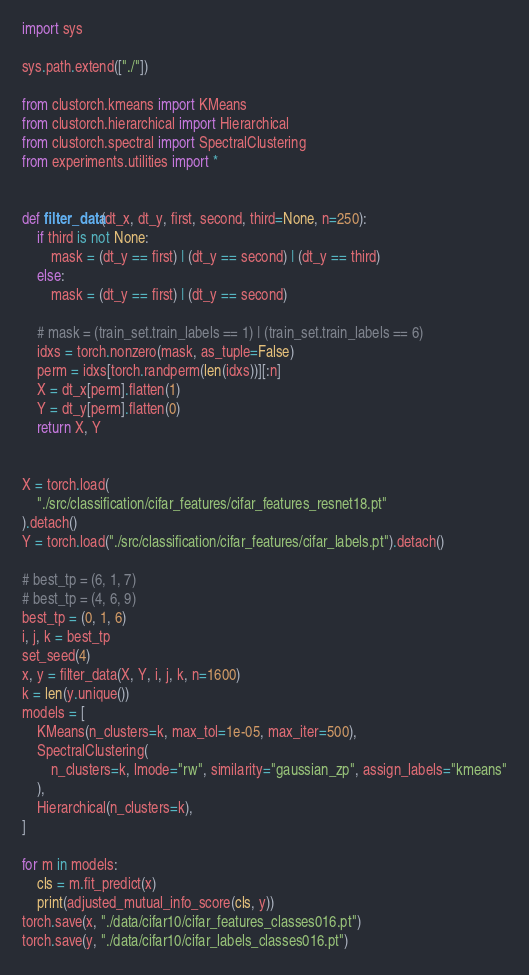Convert code to text. <code><loc_0><loc_0><loc_500><loc_500><_Python_>import sys

sys.path.extend(["./"])

from clustorch.kmeans import KMeans
from clustorch.hierarchical import Hierarchical
from clustorch.spectral import SpectralClustering
from experiments.utilities import *


def filter_data(dt_x, dt_y, first, second, third=None, n=250):
    if third is not None:
        mask = (dt_y == first) | (dt_y == second) | (dt_y == third)
    else:
        mask = (dt_y == first) | (dt_y == second)

    # mask = (train_set.train_labels == 1) | (train_set.train_labels == 6)
    idxs = torch.nonzero(mask, as_tuple=False)
    perm = idxs[torch.randperm(len(idxs))][:n]
    X = dt_x[perm].flatten(1)
    Y = dt_y[perm].flatten(0)
    return X, Y


X = torch.load(
    "./src/classification/cifar_features/cifar_features_resnet18.pt"
).detach()
Y = torch.load("./src/classification/cifar_features/cifar_labels.pt").detach()

# best_tp = (6, 1, 7)
# best_tp = (4, 6, 9)
best_tp = (0, 1, 6)
i, j, k = best_tp
set_seed(4)
x, y = filter_data(X, Y, i, j, k, n=1600)
k = len(y.unique())
models = [
    KMeans(n_clusters=k, max_tol=1e-05, max_iter=500),
    SpectralClustering(
        n_clusters=k, lmode="rw", similarity="gaussian_zp", assign_labels="kmeans"
    ),
    Hierarchical(n_clusters=k),
]

for m in models:
    cls = m.fit_predict(x)
    print(adjusted_mutual_info_score(cls, y))
torch.save(x, "./data/cifar10/cifar_features_classes016.pt")
torch.save(y, "./data/cifar10/cifar_labels_classes016.pt")
</code> 